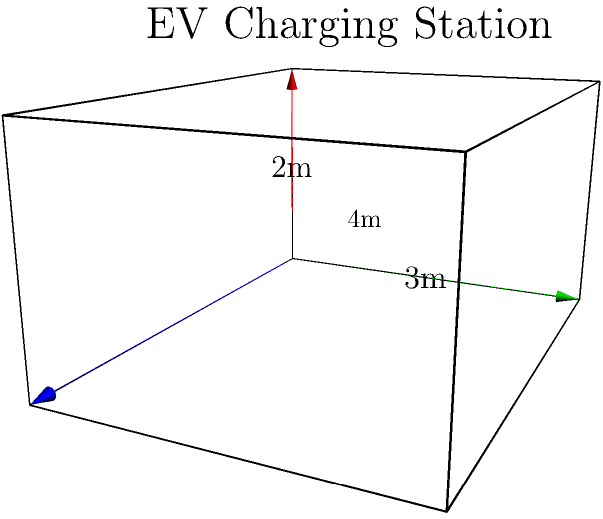As part of your sustainable energy initiative, you're designing a new cuboid-shaped EV charging station. The station has dimensions of 4 meters in length, 3 meters in width, and 2 meters in height. What is the volume of this charging station in cubic meters? To calculate the volume of a cuboid (rectangular prism), we use the formula:

$$V = l \times w \times h$$

Where:
$V$ = volume
$l$ = length
$w$ = width
$h$ = height

Given dimensions:
Length ($l$) = 4 meters
Width ($w$) = 3 meters
Height ($h$) = 2 meters

Substituting these values into the formula:

$$V = 4 \text{ m} \times 3 \text{ m} \times 2 \text{ m}$$

$$V = 24 \text{ m}^3$$

Therefore, the volume of the EV charging station is 24 cubic meters.
Answer: $24 \text{ m}^3$ 